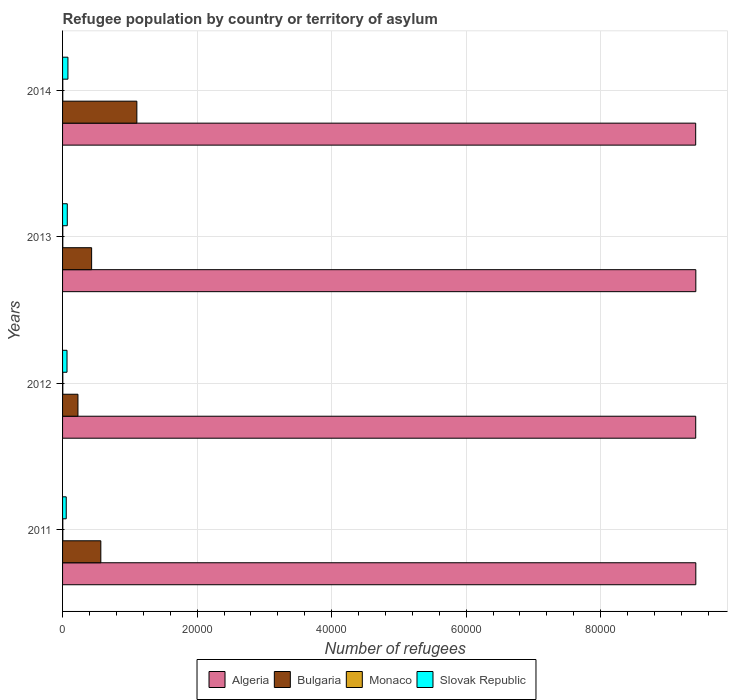How many different coloured bars are there?
Your answer should be compact. 4. How many groups of bars are there?
Offer a terse response. 4. Are the number of bars per tick equal to the number of legend labels?
Provide a short and direct response. Yes. How many bars are there on the 3rd tick from the bottom?
Provide a succinct answer. 4. What is the label of the 4th group of bars from the top?
Your answer should be very brief. 2011. In how many cases, is the number of bars for a given year not equal to the number of legend labels?
Provide a succinct answer. 0. What is the number of refugees in Monaco in 2012?
Your answer should be compact. 37. Across all years, what is the minimum number of refugees in Slovak Republic?
Make the answer very short. 546. In which year was the number of refugees in Algeria maximum?
Make the answer very short. 2013. What is the total number of refugees in Bulgaria in the graph?
Offer a very short reply. 2.33e+04. What is the difference between the number of refugees in Algeria in 2011 and that in 2013?
Make the answer very short. -2. What is the difference between the number of refugees in Bulgaria in 2011 and the number of refugees in Algeria in 2012?
Keep it short and to the point. -8.84e+04. What is the average number of refugees in Algeria per year?
Provide a short and direct response. 9.41e+04. In the year 2013, what is the difference between the number of refugees in Monaco and number of refugees in Bulgaria?
Offer a terse response. -4286. In how many years, is the number of refugees in Bulgaria greater than 44000 ?
Your answer should be compact. 0. What is the ratio of the number of refugees in Bulgaria in 2011 to that in 2014?
Your answer should be compact. 0.51. What is the difference between the highest and the second highest number of refugees in Algeria?
Give a very brief answer. 2. What is the difference between the highest and the lowest number of refugees in Monaco?
Give a very brief answer. 4. Is the sum of the number of refugees in Bulgaria in 2011 and 2014 greater than the maximum number of refugees in Monaco across all years?
Make the answer very short. Yes. Is it the case that in every year, the sum of the number of refugees in Algeria and number of refugees in Monaco is greater than the sum of number of refugees in Slovak Republic and number of refugees in Bulgaria?
Your answer should be very brief. Yes. What does the 2nd bar from the top in 2011 represents?
Your answer should be very brief. Monaco. What does the 3rd bar from the bottom in 2011 represents?
Give a very brief answer. Monaco. How many bars are there?
Make the answer very short. 16. Are all the bars in the graph horizontal?
Keep it short and to the point. Yes. How many years are there in the graph?
Keep it short and to the point. 4. What is the difference between two consecutive major ticks on the X-axis?
Your answer should be compact. 2.00e+04. Are the values on the major ticks of X-axis written in scientific E-notation?
Your answer should be compact. No. Does the graph contain any zero values?
Make the answer very short. No. Where does the legend appear in the graph?
Ensure brevity in your answer.  Bottom center. What is the title of the graph?
Offer a very short reply. Refugee population by country or territory of asylum. Does "Colombia" appear as one of the legend labels in the graph?
Your answer should be compact. No. What is the label or title of the X-axis?
Give a very brief answer. Number of refugees. What is the Number of refugees of Algeria in 2011?
Your answer should be compact. 9.41e+04. What is the Number of refugees in Bulgaria in 2011?
Offer a very short reply. 5688. What is the Number of refugees of Monaco in 2011?
Your response must be concise. 37. What is the Number of refugees in Slovak Republic in 2011?
Offer a terse response. 546. What is the Number of refugees in Algeria in 2012?
Your response must be concise. 9.41e+04. What is the Number of refugees in Bulgaria in 2012?
Keep it short and to the point. 2288. What is the Number of refugees in Slovak Republic in 2012?
Give a very brief answer. 662. What is the Number of refugees of Algeria in 2013?
Provide a short and direct response. 9.42e+04. What is the Number of refugees of Bulgaria in 2013?
Offer a terse response. 4320. What is the Number of refugees of Monaco in 2013?
Provide a succinct answer. 34. What is the Number of refugees of Slovak Republic in 2013?
Make the answer very short. 701. What is the Number of refugees of Algeria in 2014?
Give a very brief answer. 9.41e+04. What is the Number of refugees of Bulgaria in 2014?
Offer a terse response. 1.10e+04. What is the Number of refugees of Slovak Republic in 2014?
Provide a short and direct response. 799. Across all years, what is the maximum Number of refugees of Algeria?
Offer a terse response. 9.42e+04. Across all years, what is the maximum Number of refugees in Bulgaria?
Ensure brevity in your answer.  1.10e+04. Across all years, what is the maximum Number of refugees of Slovak Republic?
Provide a succinct answer. 799. Across all years, what is the minimum Number of refugees of Algeria?
Provide a short and direct response. 9.41e+04. Across all years, what is the minimum Number of refugees in Bulgaria?
Make the answer very short. 2288. Across all years, what is the minimum Number of refugees of Slovak Republic?
Your answer should be very brief. 546. What is the total Number of refugees in Algeria in the graph?
Your answer should be very brief. 3.77e+05. What is the total Number of refugees of Bulgaria in the graph?
Give a very brief answer. 2.33e+04. What is the total Number of refugees of Monaco in the graph?
Your answer should be very brief. 141. What is the total Number of refugees of Slovak Republic in the graph?
Your response must be concise. 2708. What is the difference between the Number of refugees in Bulgaria in 2011 and that in 2012?
Make the answer very short. 3400. What is the difference between the Number of refugees of Monaco in 2011 and that in 2012?
Your answer should be very brief. 0. What is the difference between the Number of refugees of Slovak Republic in 2011 and that in 2012?
Keep it short and to the point. -116. What is the difference between the Number of refugees in Bulgaria in 2011 and that in 2013?
Provide a short and direct response. 1368. What is the difference between the Number of refugees in Monaco in 2011 and that in 2013?
Your answer should be compact. 3. What is the difference between the Number of refugees in Slovak Republic in 2011 and that in 2013?
Offer a very short reply. -155. What is the difference between the Number of refugees in Algeria in 2011 and that in 2014?
Ensure brevity in your answer.  20. What is the difference between the Number of refugees of Bulgaria in 2011 and that in 2014?
Offer a terse response. -5358. What is the difference between the Number of refugees of Monaco in 2011 and that in 2014?
Provide a succinct answer. 4. What is the difference between the Number of refugees of Slovak Republic in 2011 and that in 2014?
Give a very brief answer. -253. What is the difference between the Number of refugees in Algeria in 2012 and that in 2013?
Ensure brevity in your answer.  -17. What is the difference between the Number of refugees of Bulgaria in 2012 and that in 2013?
Provide a short and direct response. -2032. What is the difference between the Number of refugees in Slovak Republic in 2012 and that in 2013?
Ensure brevity in your answer.  -39. What is the difference between the Number of refugees in Algeria in 2012 and that in 2014?
Make the answer very short. 5. What is the difference between the Number of refugees of Bulgaria in 2012 and that in 2014?
Offer a terse response. -8758. What is the difference between the Number of refugees in Slovak Republic in 2012 and that in 2014?
Keep it short and to the point. -137. What is the difference between the Number of refugees in Bulgaria in 2013 and that in 2014?
Provide a short and direct response. -6726. What is the difference between the Number of refugees in Monaco in 2013 and that in 2014?
Give a very brief answer. 1. What is the difference between the Number of refugees of Slovak Republic in 2013 and that in 2014?
Your answer should be compact. -98. What is the difference between the Number of refugees in Algeria in 2011 and the Number of refugees in Bulgaria in 2012?
Make the answer very short. 9.19e+04. What is the difference between the Number of refugees of Algeria in 2011 and the Number of refugees of Monaco in 2012?
Your answer should be very brief. 9.41e+04. What is the difference between the Number of refugees of Algeria in 2011 and the Number of refugees of Slovak Republic in 2012?
Ensure brevity in your answer.  9.35e+04. What is the difference between the Number of refugees in Bulgaria in 2011 and the Number of refugees in Monaco in 2012?
Give a very brief answer. 5651. What is the difference between the Number of refugees in Bulgaria in 2011 and the Number of refugees in Slovak Republic in 2012?
Offer a very short reply. 5026. What is the difference between the Number of refugees of Monaco in 2011 and the Number of refugees of Slovak Republic in 2012?
Ensure brevity in your answer.  -625. What is the difference between the Number of refugees in Algeria in 2011 and the Number of refugees in Bulgaria in 2013?
Provide a short and direct response. 8.98e+04. What is the difference between the Number of refugees of Algeria in 2011 and the Number of refugees of Monaco in 2013?
Offer a very short reply. 9.41e+04. What is the difference between the Number of refugees in Algeria in 2011 and the Number of refugees in Slovak Republic in 2013?
Your answer should be compact. 9.34e+04. What is the difference between the Number of refugees in Bulgaria in 2011 and the Number of refugees in Monaco in 2013?
Provide a succinct answer. 5654. What is the difference between the Number of refugees of Bulgaria in 2011 and the Number of refugees of Slovak Republic in 2013?
Provide a succinct answer. 4987. What is the difference between the Number of refugees of Monaco in 2011 and the Number of refugees of Slovak Republic in 2013?
Offer a terse response. -664. What is the difference between the Number of refugees in Algeria in 2011 and the Number of refugees in Bulgaria in 2014?
Offer a very short reply. 8.31e+04. What is the difference between the Number of refugees of Algeria in 2011 and the Number of refugees of Monaco in 2014?
Provide a short and direct response. 9.41e+04. What is the difference between the Number of refugees of Algeria in 2011 and the Number of refugees of Slovak Republic in 2014?
Offer a terse response. 9.33e+04. What is the difference between the Number of refugees in Bulgaria in 2011 and the Number of refugees in Monaco in 2014?
Your answer should be very brief. 5655. What is the difference between the Number of refugees of Bulgaria in 2011 and the Number of refugees of Slovak Republic in 2014?
Give a very brief answer. 4889. What is the difference between the Number of refugees in Monaco in 2011 and the Number of refugees in Slovak Republic in 2014?
Your answer should be very brief. -762. What is the difference between the Number of refugees of Algeria in 2012 and the Number of refugees of Bulgaria in 2013?
Your answer should be very brief. 8.98e+04. What is the difference between the Number of refugees of Algeria in 2012 and the Number of refugees of Monaco in 2013?
Provide a succinct answer. 9.41e+04. What is the difference between the Number of refugees of Algeria in 2012 and the Number of refugees of Slovak Republic in 2013?
Give a very brief answer. 9.34e+04. What is the difference between the Number of refugees in Bulgaria in 2012 and the Number of refugees in Monaco in 2013?
Ensure brevity in your answer.  2254. What is the difference between the Number of refugees in Bulgaria in 2012 and the Number of refugees in Slovak Republic in 2013?
Your response must be concise. 1587. What is the difference between the Number of refugees of Monaco in 2012 and the Number of refugees of Slovak Republic in 2013?
Ensure brevity in your answer.  -664. What is the difference between the Number of refugees of Algeria in 2012 and the Number of refugees of Bulgaria in 2014?
Give a very brief answer. 8.31e+04. What is the difference between the Number of refugees in Algeria in 2012 and the Number of refugees in Monaco in 2014?
Provide a short and direct response. 9.41e+04. What is the difference between the Number of refugees of Algeria in 2012 and the Number of refugees of Slovak Republic in 2014?
Offer a terse response. 9.33e+04. What is the difference between the Number of refugees of Bulgaria in 2012 and the Number of refugees of Monaco in 2014?
Your response must be concise. 2255. What is the difference between the Number of refugees of Bulgaria in 2012 and the Number of refugees of Slovak Republic in 2014?
Provide a succinct answer. 1489. What is the difference between the Number of refugees of Monaco in 2012 and the Number of refugees of Slovak Republic in 2014?
Offer a terse response. -762. What is the difference between the Number of refugees of Algeria in 2013 and the Number of refugees of Bulgaria in 2014?
Offer a terse response. 8.31e+04. What is the difference between the Number of refugees of Algeria in 2013 and the Number of refugees of Monaco in 2014?
Keep it short and to the point. 9.41e+04. What is the difference between the Number of refugees of Algeria in 2013 and the Number of refugees of Slovak Republic in 2014?
Provide a short and direct response. 9.34e+04. What is the difference between the Number of refugees of Bulgaria in 2013 and the Number of refugees of Monaco in 2014?
Make the answer very short. 4287. What is the difference between the Number of refugees in Bulgaria in 2013 and the Number of refugees in Slovak Republic in 2014?
Give a very brief answer. 3521. What is the difference between the Number of refugees in Monaco in 2013 and the Number of refugees in Slovak Republic in 2014?
Your response must be concise. -765. What is the average Number of refugees of Algeria per year?
Provide a short and direct response. 9.41e+04. What is the average Number of refugees of Bulgaria per year?
Keep it short and to the point. 5835.5. What is the average Number of refugees of Monaco per year?
Provide a succinct answer. 35.25. What is the average Number of refugees in Slovak Republic per year?
Ensure brevity in your answer.  677. In the year 2011, what is the difference between the Number of refugees of Algeria and Number of refugees of Bulgaria?
Your response must be concise. 8.85e+04. In the year 2011, what is the difference between the Number of refugees of Algeria and Number of refugees of Monaco?
Offer a very short reply. 9.41e+04. In the year 2011, what is the difference between the Number of refugees in Algeria and Number of refugees in Slovak Republic?
Provide a short and direct response. 9.36e+04. In the year 2011, what is the difference between the Number of refugees of Bulgaria and Number of refugees of Monaco?
Offer a very short reply. 5651. In the year 2011, what is the difference between the Number of refugees of Bulgaria and Number of refugees of Slovak Republic?
Keep it short and to the point. 5142. In the year 2011, what is the difference between the Number of refugees in Monaco and Number of refugees in Slovak Republic?
Ensure brevity in your answer.  -509. In the year 2012, what is the difference between the Number of refugees of Algeria and Number of refugees of Bulgaria?
Offer a terse response. 9.18e+04. In the year 2012, what is the difference between the Number of refugees of Algeria and Number of refugees of Monaco?
Make the answer very short. 9.41e+04. In the year 2012, what is the difference between the Number of refugees in Algeria and Number of refugees in Slovak Republic?
Ensure brevity in your answer.  9.35e+04. In the year 2012, what is the difference between the Number of refugees of Bulgaria and Number of refugees of Monaco?
Provide a short and direct response. 2251. In the year 2012, what is the difference between the Number of refugees in Bulgaria and Number of refugees in Slovak Republic?
Make the answer very short. 1626. In the year 2012, what is the difference between the Number of refugees of Monaco and Number of refugees of Slovak Republic?
Make the answer very short. -625. In the year 2013, what is the difference between the Number of refugees in Algeria and Number of refugees in Bulgaria?
Your answer should be compact. 8.98e+04. In the year 2013, what is the difference between the Number of refugees in Algeria and Number of refugees in Monaco?
Keep it short and to the point. 9.41e+04. In the year 2013, what is the difference between the Number of refugees of Algeria and Number of refugees of Slovak Republic?
Give a very brief answer. 9.34e+04. In the year 2013, what is the difference between the Number of refugees in Bulgaria and Number of refugees in Monaco?
Your response must be concise. 4286. In the year 2013, what is the difference between the Number of refugees of Bulgaria and Number of refugees of Slovak Republic?
Give a very brief answer. 3619. In the year 2013, what is the difference between the Number of refugees of Monaco and Number of refugees of Slovak Republic?
Provide a short and direct response. -667. In the year 2014, what is the difference between the Number of refugees of Algeria and Number of refugees of Bulgaria?
Ensure brevity in your answer.  8.31e+04. In the year 2014, what is the difference between the Number of refugees in Algeria and Number of refugees in Monaco?
Give a very brief answer. 9.41e+04. In the year 2014, what is the difference between the Number of refugees in Algeria and Number of refugees in Slovak Republic?
Offer a very short reply. 9.33e+04. In the year 2014, what is the difference between the Number of refugees in Bulgaria and Number of refugees in Monaco?
Your answer should be compact. 1.10e+04. In the year 2014, what is the difference between the Number of refugees of Bulgaria and Number of refugees of Slovak Republic?
Provide a short and direct response. 1.02e+04. In the year 2014, what is the difference between the Number of refugees in Monaco and Number of refugees in Slovak Republic?
Ensure brevity in your answer.  -766. What is the ratio of the Number of refugees of Bulgaria in 2011 to that in 2012?
Ensure brevity in your answer.  2.49. What is the ratio of the Number of refugees in Monaco in 2011 to that in 2012?
Keep it short and to the point. 1. What is the ratio of the Number of refugees in Slovak Republic in 2011 to that in 2012?
Give a very brief answer. 0.82. What is the ratio of the Number of refugees of Algeria in 2011 to that in 2013?
Your response must be concise. 1. What is the ratio of the Number of refugees in Bulgaria in 2011 to that in 2013?
Your answer should be very brief. 1.32. What is the ratio of the Number of refugees in Monaco in 2011 to that in 2013?
Provide a short and direct response. 1.09. What is the ratio of the Number of refugees in Slovak Republic in 2011 to that in 2013?
Provide a short and direct response. 0.78. What is the ratio of the Number of refugees in Algeria in 2011 to that in 2014?
Make the answer very short. 1. What is the ratio of the Number of refugees in Bulgaria in 2011 to that in 2014?
Provide a short and direct response. 0.51. What is the ratio of the Number of refugees of Monaco in 2011 to that in 2014?
Your answer should be compact. 1.12. What is the ratio of the Number of refugees in Slovak Republic in 2011 to that in 2014?
Your answer should be compact. 0.68. What is the ratio of the Number of refugees in Algeria in 2012 to that in 2013?
Your answer should be very brief. 1. What is the ratio of the Number of refugees in Bulgaria in 2012 to that in 2013?
Provide a succinct answer. 0.53. What is the ratio of the Number of refugees in Monaco in 2012 to that in 2013?
Give a very brief answer. 1.09. What is the ratio of the Number of refugees in Bulgaria in 2012 to that in 2014?
Your response must be concise. 0.21. What is the ratio of the Number of refugees in Monaco in 2012 to that in 2014?
Ensure brevity in your answer.  1.12. What is the ratio of the Number of refugees in Slovak Republic in 2012 to that in 2014?
Keep it short and to the point. 0.83. What is the ratio of the Number of refugees of Bulgaria in 2013 to that in 2014?
Give a very brief answer. 0.39. What is the ratio of the Number of refugees of Monaco in 2013 to that in 2014?
Your answer should be very brief. 1.03. What is the ratio of the Number of refugees in Slovak Republic in 2013 to that in 2014?
Give a very brief answer. 0.88. What is the difference between the highest and the second highest Number of refugees in Algeria?
Ensure brevity in your answer.  2. What is the difference between the highest and the second highest Number of refugees in Bulgaria?
Offer a very short reply. 5358. What is the difference between the highest and the second highest Number of refugees of Monaco?
Provide a succinct answer. 0. What is the difference between the highest and the second highest Number of refugees in Slovak Republic?
Keep it short and to the point. 98. What is the difference between the highest and the lowest Number of refugees in Algeria?
Your response must be concise. 22. What is the difference between the highest and the lowest Number of refugees of Bulgaria?
Your answer should be very brief. 8758. What is the difference between the highest and the lowest Number of refugees in Monaco?
Ensure brevity in your answer.  4. What is the difference between the highest and the lowest Number of refugees of Slovak Republic?
Keep it short and to the point. 253. 